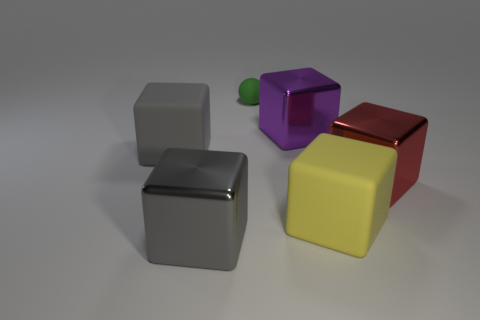Is there anything else that has the same size as the gray metallic cube?
Keep it short and to the point. Yes. How many metal things are large red cubes or cylinders?
Your answer should be very brief. 1. Is there a big purple shiny block?
Offer a terse response. Yes. What color is the large block that is right of the large rubber block that is on the right side of the gray rubber thing?
Keep it short and to the point. Red. How many other objects are there of the same color as the sphere?
Your answer should be compact. 0. What number of objects are either big yellow cylinders or big metallic things that are behind the gray metal block?
Your response must be concise. 2. There is a small ball on the left side of the large yellow rubber thing; what color is it?
Provide a short and direct response. Green. What shape is the gray metallic object?
Give a very brief answer. Cube. The gray thing that is in front of the matte cube that is behind the red metal object is made of what material?
Make the answer very short. Metal. What number of other objects are the same material as the small ball?
Keep it short and to the point. 2. 